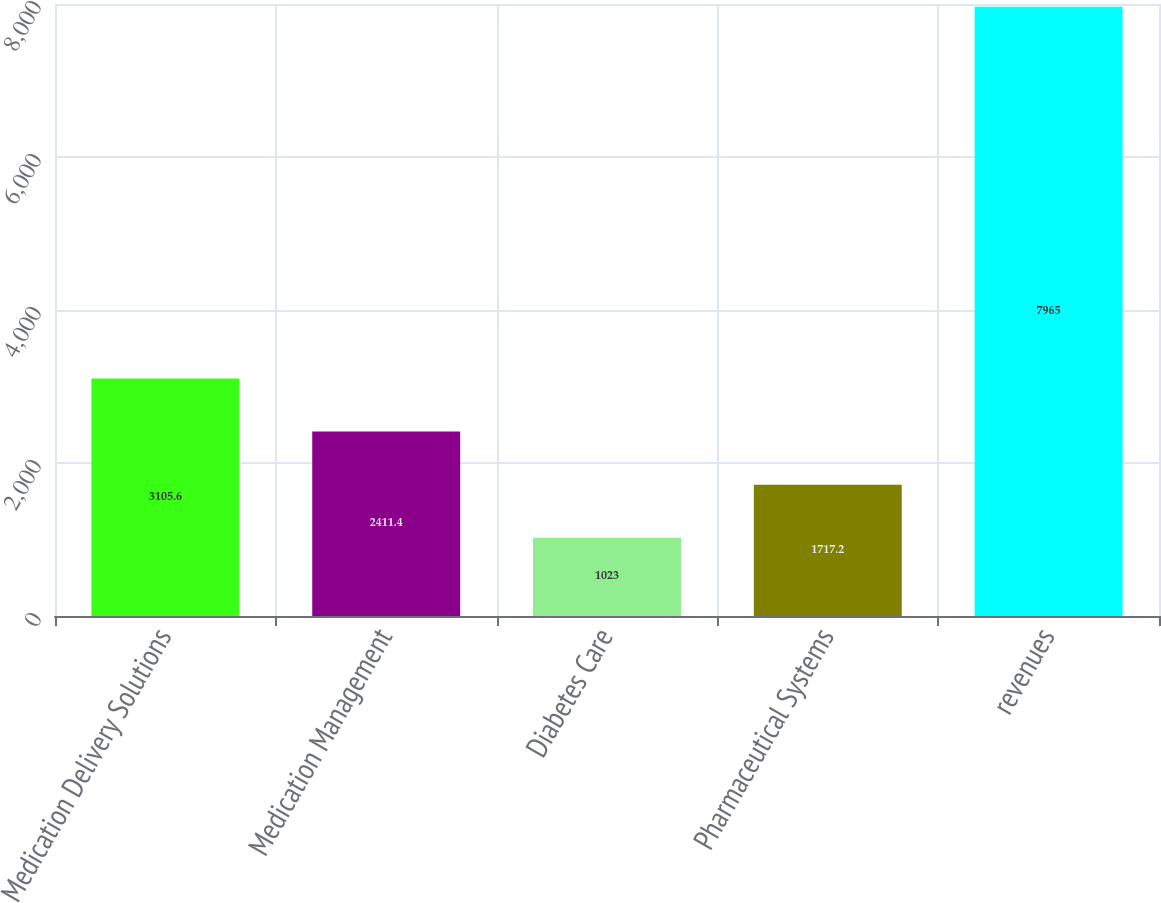Convert chart to OTSL. <chart><loc_0><loc_0><loc_500><loc_500><bar_chart><fcel>Medication Delivery Solutions<fcel>Medication Management<fcel>Diabetes Care<fcel>Pharmaceutical Systems<fcel>revenues<nl><fcel>3105.6<fcel>2411.4<fcel>1023<fcel>1717.2<fcel>7965<nl></chart> 